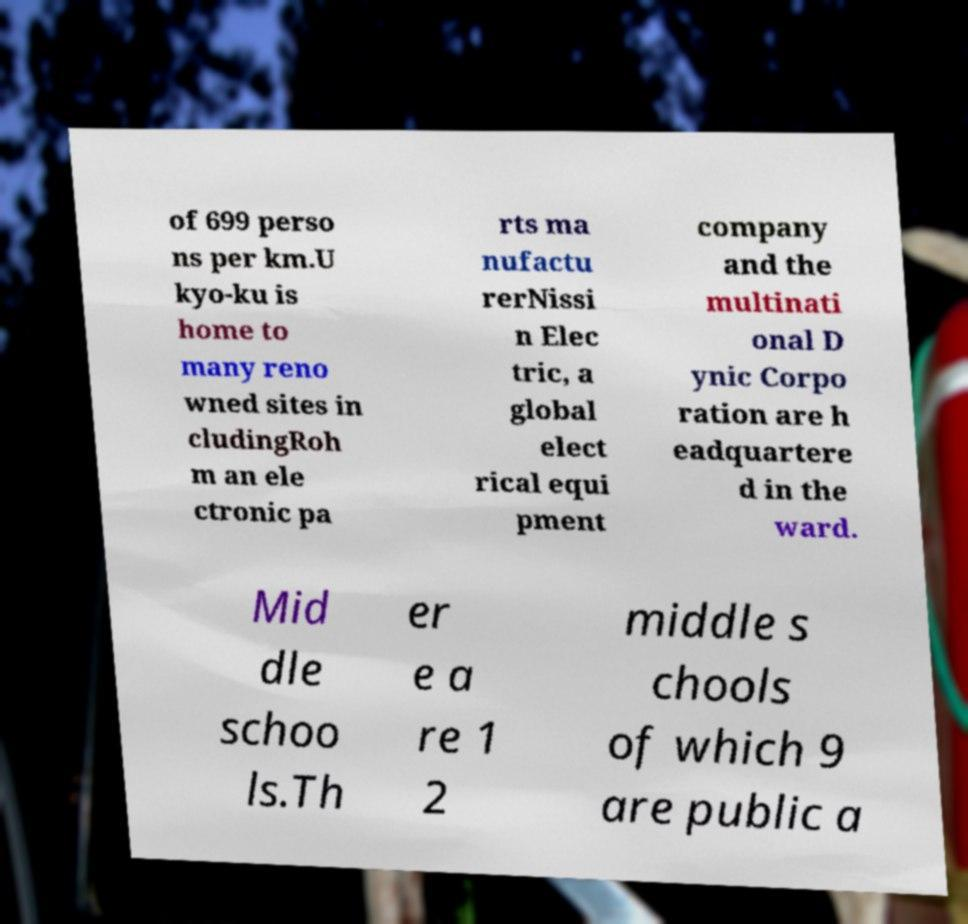Can you read and provide the text displayed in the image?This photo seems to have some interesting text. Can you extract and type it out for me? of 699 perso ns per km.U kyo-ku is home to many reno wned sites in cludingRoh m an ele ctronic pa rts ma nufactu rerNissi n Elec tric, a global elect rical equi pment company and the multinati onal D ynic Corpo ration are h eadquartere d in the ward. Mid dle schoo ls.Th er e a re 1 2 middle s chools of which 9 are public a 